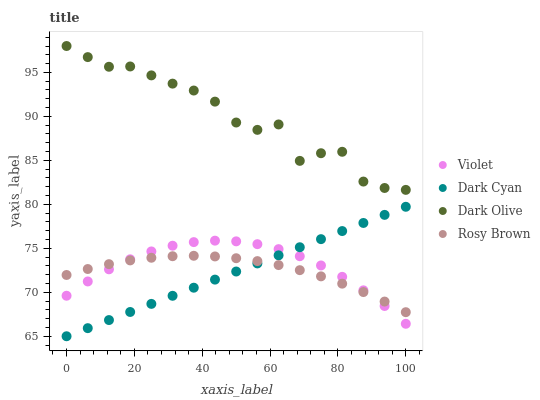Does Dark Cyan have the minimum area under the curve?
Answer yes or no. Yes. Does Dark Olive have the maximum area under the curve?
Answer yes or no. Yes. Does Rosy Brown have the minimum area under the curve?
Answer yes or no. No. Does Rosy Brown have the maximum area under the curve?
Answer yes or no. No. Is Dark Cyan the smoothest?
Answer yes or no. Yes. Is Dark Olive the roughest?
Answer yes or no. Yes. Is Rosy Brown the smoothest?
Answer yes or no. No. Is Rosy Brown the roughest?
Answer yes or no. No. Does Dark Cyan have the lowest value?
Answer yes or no. Yes. Does Rosy Brown have the lowest value?
Answer yes or no. No. Does Dark Olive have the highest value?
Answer yes or no. Yes. Does Rosy Brown have the highest value?
Answer yes or no. No. Is Dark Cyan less than Dark Olive?
Answer yes or no. Yes. Is Dark Olive greater than Violet?
Answer yes or no. Yes. Does Rosy Brown intersect Dark Cyan?
Answer yes or no. Yes. Is Rosy Brown less than Dark Cyan?
Answer yes or no. No. Is Rosy Brown greater than Dark Cyan?
Answer yes or no. No. Does Dark Cyan intersect Dark Olive?
Answer yes or no. No. 